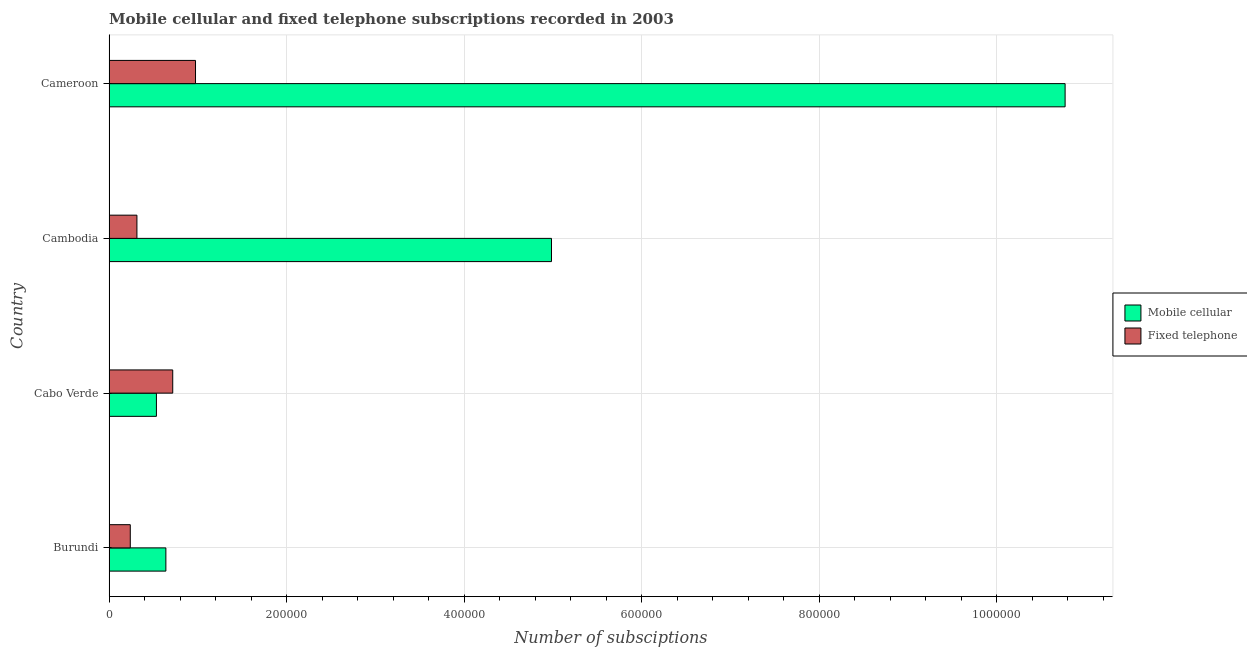How many groups of bars are there?
Provide a succinct answer. 4. Are the number of bars per tick equal to the number of legend labels?
Keep it short and to the point. Yes. How many bars are there on the 4th tick from the top?
Offer a very short reply. 2. How many bars are there on the 1st tick from the bottom?
Your answer should be very brief. 2. What is the label of the 3rd group of bars from the top?
Give a very brief answer. Cabo Verde. In how many cases, is the number of bars for a given country not equal to the number of legend labels?
Give a very brief answer. 0. What is the number of fixed telephone subscriptions in Cameroon?
Provide a succinct answer. 9.74e+04. Across all countries, what is the maximum number of fixed telephone subscriptions?
Your answer should be compact. 9.74e+04. Across all countries, what is the minimum number of mobile cellular subscriptions?
Give a very brief answer. 5.33e+04. In which country was the number of mobile cellular subscriptions maximum?
Your response must be concise. Cameroon. In which country was the number of mobile cellular subscriptions minimum?
Ensure brevity in your answer.  Cabo Verde. What is the total number of fixed telephone subscriptions in the graph?
Offer a terse response. 2.24e+05. What is the difference between the number of fixed telephone subscriptions in Cabo Verde and that in Cameroon?
Offer a terse response. -2.57e+04. What is the difference between the number of fixed telephone subscriptions in Burundi and the number of mobile cellular subscriptions in Cambodia?
Your answer should be compact. -4.74e+05. What is the average number of fixed telephone subscriptions per country?
Offer a very short reply. 5.61e+04. What is the difference between the number of mobile cellular subscriptions and number of fixed telephone subscriptions in Cabo Verde?
Offer a terse response. -1.84e+04. In how many countries, is the number of mobile cellular subscriptions greater than 240000 ?
Your answer should be compact. 2. Is the difference between the number of fixed telephone subscriptions in Cabo Verde and Cambodia greater than the difference between the number of mobile cellular subscriptions in Cabo Verde and Cambodia?
Provide a short and direct response. Yes. What is the difference between the highest and the second highest number of fixed telephone subscriptions?
Provide a succinct answer. 2.57e+04. What is the difference between the highest and the lowest number of fixed telephone subscriptions?
Provide a short and direct response. 7.35e+04. Is the sum of the number of mobile cellular subscriptions in Burundi and Cameroon greater than the maximum number of fixed telephone subscriptions across all countries?
Make the answer very short. Yes. What does the 2nd bar from the top in Burundi represents?
Provide a succinct answer. Mobile cellular. What does the 1st bar from the bottom in Cambodia represents?
Make the answer very short. Mobile cellular. What is the difference between two consecutive major ticks on the X-axis?
Offer a terse response. 2.00e+05. Are the values on the major ticks of X-axis written in scientific E-notation?
Give a very brief answer. No. Does the graph contain grids?
Give a very brief answer. Yes. How are the legend labels stacked?
Keep it short and to the point. Vertical. What is the title of the graph?
Your answer should be very brief. Mobile cellular and fixed telephone subscriptions recorded in 2003. What is the label or title of the X-axis?
Make the answer very short. Number of subsciptions. What is the label or title of the Y-axis?
Keep it short and to the point. Country. What is the Number of subsciptions of Mobile cellular in Burundi?
Make the answer very short. 6.40e+04. What is the Number of subsciptions in Fixed telephone in Burundi?
Your answer should be compact. 2.39e+04. What is the Number of subsciptions of Mobile cellular in Cabo Verde?
Keep it short and to the point. 5.33e+04. What is the Number of subsciptions of Fixed telephone in Cabo Verde?
Provide a succinct answer. 7.17e+04. What is the Number of subsciptions of Mobile cellular in Cambodia?
Your answer should be compact. 4.98e+05. What is the Number of subsciptions in Fixed telephone in Cambodia?
Make the answer very short. 3.14e+04. What is the Number of subsciptions in Mobile cellular in Cameroon?
Offer a very short reply. 1.08e+06. What is the Number of subsciptions in Fixed telephone in Cameroon?
Your answer should be very brief. 9.74e+04. Across all countries, what is the maximum Number of subsciptions of Mobile cellular?
Provide a succinct answer. 1.08e+06. Across all countries, what is the maximum Number of subsciptions of Fixed telephone?
Offer a very short reply. 9.74e+04. Across all countries, what is the minimum Number of subsciptions of Mobile cellular?
Keep it short and to the point. 5.33e+04. Across all countries, what is the minimum Number of subsciptions of Fixed telephone?
Offer a terse response. 2.39e+04. What is the total Number of subsciptions of Mobile cellular in the graph?
Provide a succinct answer. 1.69e+06. What is the total Number of subsciptions of Fixed telephone in the graph?
Offer a terse response. 2.24e+05. What is the difference between the Number of subsciptions of Mobile cellular in Burundi and that in Cabo Verde?
Your answer should be compact. 1.07e+04. What is the difference between the Number of subsciptions of Fixed telephone in Burundi and that in Cabo Verde?
Provide a short and direct response. -4.78e+04. What is the difference between the Number of subsciptions in Mobile cellular in Burundi and that in Cambodia?
Provide a short and direct response. -4.34e+05. What is the difference between the Number of subsciptions of Fixed telephone in Burundi and that in Cambodia?
Offer a very short reply. -7484. What is the difference between the Number of subsciptions of Mobile cellular in Burundi and that in Cameroon?
Your answer should be very brief. -1.01e+06. What is the difference between the Number of subsciptions in Fixed telephone in Burundi and that in Cameroon?
Keep it short and to the point. -7.35e+04. What is the difference between the Number of subsciptions of Mobile cellular in Cabo Verde and that in Cambodia?
Offer a very short reply. -4.45e+05. What is the difference between the Number of subsciptions of Fixed telephone in Cabo Verde and that in Cambodia?
Your answer should be very brief. 4.03e+04. What is the difference between the Number of subsciptions in Mobile cellular in Cabo Verde and that in Cameroon?
Your answer should be compact. -1.02e+06. What is the difference between the Number of subsciptions of Fixed telephone in Cabo Verde and that in Cameroon?
Give a very brief answer. -2.57e+04. What is the difference between the Number of subsciptions in Mobile cellular in Cambodia and that in Cameroon?
Keep it short and to the point. -5.79e+05. What is the difference between the Number of subsciptions in Fixed telephone in Cambodia and that in Cameroon?
Provide a succinct answer. -6.60e+04. What is the difference between the Number of subsciptions of Mobile cellular in Burundi and the Number of subsciptions of Fixed telephone in Cabo Verde?
Your response must be concise. -7716. What is the difference between the Number of subsciptions of Mobile cellular in Burundi and the Number of subsciptions of Fixed telephone in Cambodia?
Ensure brevity in your answer.  3.26e+04. What is the difference between the Number of subsciptions in Mobile cellular in Burundi and the Number of subsciptions in Fixed telephone in Cameroon?
Your answer should be compact. -3.34e+04. What is the difference between the Number of subsciptions of Mobile cellular in Cabo Verde and the Number of subsciptions of Fixed telephone in Cambodia?
Your answer should be very brief. 2.20e+04. What is the difference between the Number of subsciptions of Mobile cellular in Cabo Verde and the Number of subsciptions of Fixed telephone in Cameroon?
Your response must be concise. -4.41e+04. What is the difference between the Number of subsciptions of Mobile cellular in Cambodia and the Number of subsciptions of Fixed telephone in Cameroon?
Provide a short and direct response. 4.01e+05. What is the average Number of subsciptions in Mobile cellular per country?
Your response must be concise. 4.23e+05. What is the average Number of subsciptions of Fixed telephone per country?
Your answer should be compact. 5.61e+04. What is the difference between the Number of subsciptions of Mobile cellular and Number of subsciptions of Fixed telephone in Burundi?
Your answer should be very brief. 4.01e+04. What is the difference between the Number of subsciptions of Mobile cellular and Number of subsciptions of Fixed telephone in Cabo Verde?
Make the answer very short. -1.84e+04. What is the difference between the Number of subsciptions of Mobile cellular and Number of subsciptions of Fixed telephone in Cambodia?
Offer a very short reply. 4.67e+05. What is the difference between the Number of subsciptions of Mobile cellular and Number of subsciptions of Fixed telephone in Cameroon?
Offer a very short reply. 9.80e+05. What is the ratio of the Number of subsciptions of Mobile cellular in Burundi to that in Cabo Verde?
Your response must be concise. 1.2. What is the ratio of the Number of subsciptions in Fixed telephone in Burundi to that in Cabo Verde?
Your answer should be very brief. 0.33. What is the ratio of the Number of subsciptions of Mobile cellular in Burundi to that in Cambodia?
Offer a terse response. 0.13. What is the ratio of the Number of subsciptions in Fixed telephone in Burundi to that in Cambodia?
Offer a very short reply. 0.76. What is the ratio of the Number of subsciptions of Mobile cellular in Burundi to that in Cameroon?
Your answer should be compact. 0.06. What is the ratio of the Number of subsciptions in Fixed telephone in Burundi to that in Cameroon?
Provide a short and direct response. 0.25. What is the ratio of the Number of subsciptions of Mobile cellular in Cabo Verde to that in Cambodia?
Your answer should be compact. 0.11. What is the ratio of the Number of subsciptions of Fixed telephone in Cabo Verde to that in Cambodia?
Offer a terse response. 2.29. What is the ratio of the Number of subsciptions in Mobile cellular in Cabo Verde to that in Cameroon?
Make the answer very short. 0.05. What is the ratio of the Number of subsciptions of Fixed telephone in Cabo Verde to that in Cameroon?
Your answer should be compact. 0.74. What is the ratio of the Number of subsciptions of Mobile cellular in Cambodia to that in Cameroon?
Provide a short and direct response. 0.46. What is the ratio of the Number of subsciptions of Fixed telephone in Cambodia to that in Cameroon?
Provide a succinct answer. 0.32. What is the difference between the highest and the second highest Number of subsciptions of Mobile cellular?
Your answer should be compact. 5.79e+05. What is the difference between the highest and the second highest Number of subsciptions of Fixed telephone?
Provide a short and direct response. 2.57e+04. What is the difference between the highest and the lowest Number of subsciptions in Mobile cellular?
Ensure brevity in your answer.  1.02e+06. What is the difference between the highest and the lowest Number of subsciptions in Fixed telephone?
Offer a very short reply. 7.35e+04. 